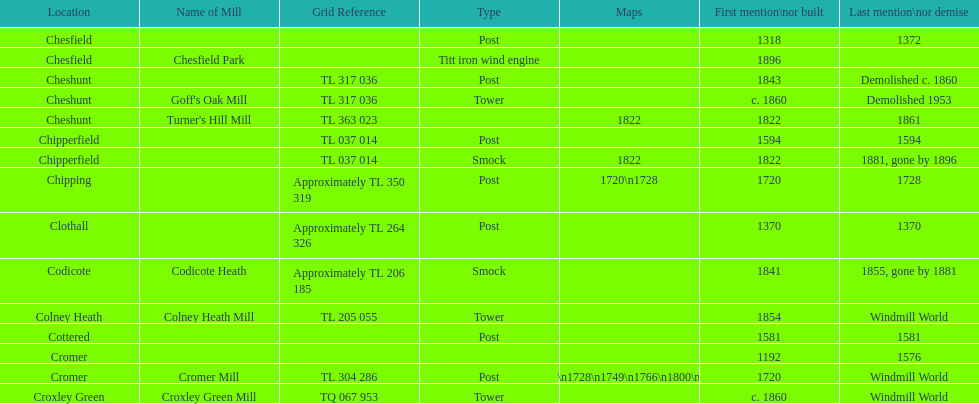How many locations have no photograph? 14. 